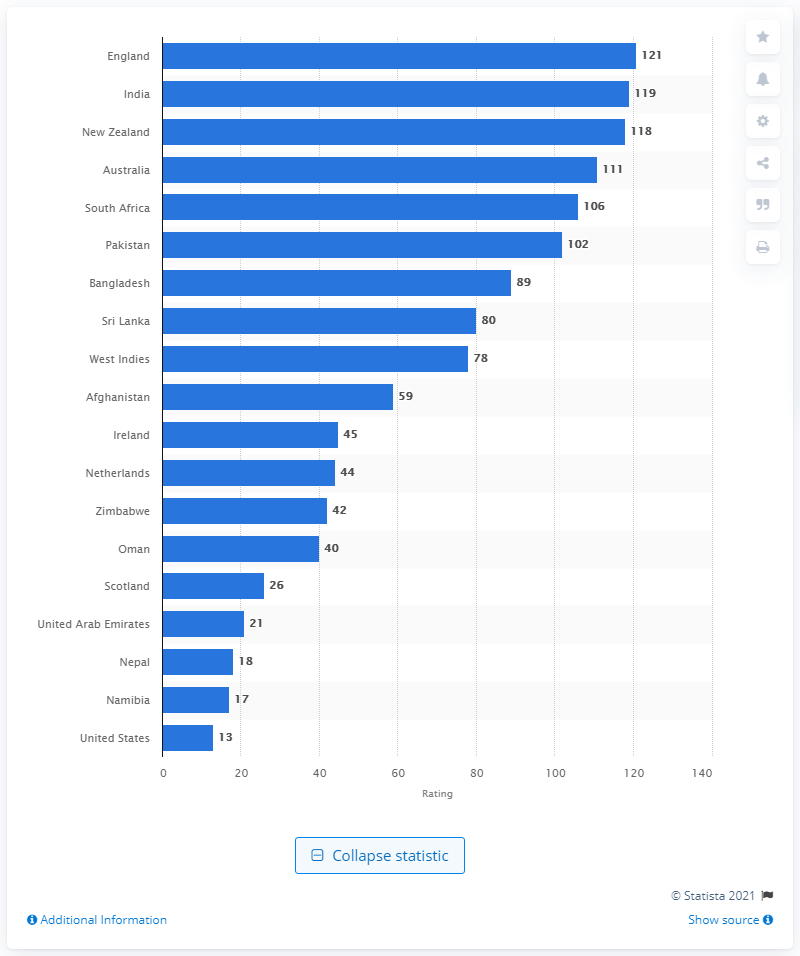Draw attention to some important aspects in this diagram. England is currently the top-ranked team in One Day International (ODI) nations. 